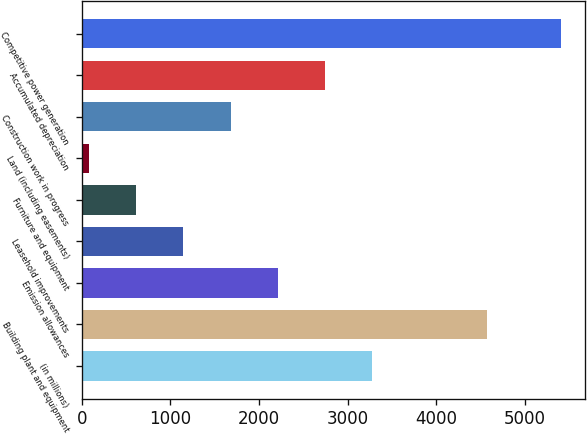Convert chart to OTSL. <chart><loc_0><loc_0><loc_500><loc_500><bar_chart><fcel>(in millions)<fcel>Building plant and equipment<fcel>Emission allowances<fcel>Leasehold improvements<fcel>Furniture and equipment<fcel>Land (including easements)<fcel>Construction work in progress<fcel>Accumulated depreciation<fcel>Competitive power generation<nl><fcel>3277.2<fcel>4572<fcel>2212.8<fcel>1148.4<fcel>616.2<fcel>84<fcel>1680.6<fcel>2745<fcel>5406<nl></chart> 